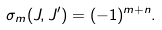<formula> <loc_0><loc_0><loc_500><loc_500>\sigma _ { m } ( J , J ^ { \prime } ) = ( - 1 ) ^ { m + n } .</formula> 